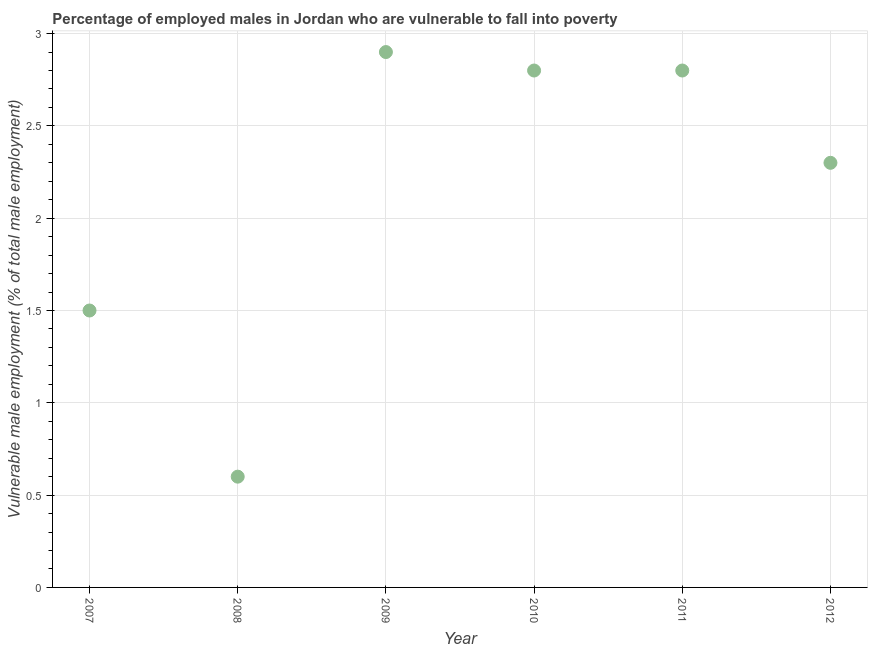What is the percentage of employed males who are vulnerable to fall into poverty in 2007?
Give a very brief answer. 1.5. Across all years, what is the maximum percentage of employed males who are vulnerable to fall into poverty?
Provide a succinct answer. 2.9. Across all years, what is the minimum percentage of employed males who are vulnerable to fall into poverty?
Your answer should be very brief. 0.6. In which year was the percentage of employed males who are vulnerable to fall into poverty maximum?
Provide a succinct answer. 2009. What is the sum of the percentage of employed males who are vulnerable to fall into poverty?
Provide a short and direct response. 12.9. What is the average percentage of employed males who are vulnerable to fall into poverty per year?
Your answer should be compact. 2.15. What is the median percentage of employed males who are vulnerable to fall into poverty?
Your answer should be compact. 2.55. What is the ratio of the percentage of employed males who are vulnerable to fall into poverty in 2010 to that in 2012?
Your answer should be very brief. 1.22. Is the percentage of employed males who are vulnerable to fall into poverty in 2009 less than that in 2010?
Provide a succinct answer. No. What is the difference between the highest and the second highest percentage of employed males who are vulnerable to fall into poverty?
Keep it short and to the point. 0.1. What is the difference between the highest and the lowest percentage of employed males who are vulnerable to fall into poverty?
Your answer should be compact. 2.3. Does the percentage of employed males who are vulnerable to fall into poverty monotonically increase over the years?
Offer a very short reply. No. How many dotlines are there?
Provide a short and direct response. 1. Are the values on the major ticks of Y-axis written in scientific E-notation?
Offer a very short reply. No. Does the graph contain grids?
Give a very brief answer. Yes. What is the title of the graph?
Your answer should be very brief. Percentage of employed males in Jordan who are vulnerable to fall into poverty. What is the label or title of the Y-axis?
Your answer should be very brief. Vulnerable male employment (% of total male employment). What is the Vulnerable male employment (% of total male employment) in 2008?
Ensure brevity in your answer.  0.6. What is the Vulnerable male employment (% of total male employment) in 2009?
Offer a very short reply. 2.9. What is the Vulnerable male employment (% of total male employment) in 2010?
Make the answer very short. 2.8. What is the Vulnerable male employment (% of total male employment) in 2011?
Offer a terse response. 2.8. What is the Vulnerable male employment (% of total male employment) in 2012?
Keep it short and to the point. 2.3. What is the difference between the Vulnerable male employment (% of total male employment) in 2007 and 2008?
Your answer should be very brief. 0.9. What is the difference between the Vulnerable male employment (% of total male employment) in 2007 and 2010?
Provide a short and direct response. -1.3. What is the difference between the Vulnerable male employment (% of total male employment) in 2007 and 2012?
Offer a very short reply. -0.8. What is the difference between the Vulnerable male employment (% of total male employment) in 2008 and 2012?
Ensure brevity in your answer.  -1.7. What is the difference between the Vulnerable male employment (% of total male employment) in 2009 and 2010?
Make the answer very short. 0.1. What is the difference between the Vulnerable male employment (% of total male employment) in 2009 and 2011?
Make the answer very short. 0.1. What is the difference between the Vulnerable male employment (% of total male employment) in 2010 and 2012?
Your answer should be compact. 0.5. What is the ratio of the Vulnerable male employment (% of total male employment) in 2007 to that in 2008?
Provide a short and direct response. 2.5. What is the ratio of the Vulnerable male employment (% of total male employment) in 2007 to that in 2009?
Make the answer very short. 0.52. What is the ratio of the Vulnerable male employment (% of total male employment) in 2007 to that in 2010?
Provide a short and direct response. 0.54. What is the ratio of the Vulnerable male employment (% of total male employment) in 2007 to that in 2011?
Make the answer very short. 0.54. What is the ratio of the Vulnerable male employment (% of total male employment) in 2007 to that in 2012?
Your answer should be compact. 0.65. What is the ratio of the Vulnerable male employment (% of total male employment) in 2008 to that in 2009?
Give a very brief answer. 0.21. What is the ratio of the Vulnerable male employment (% of total male employment) in 2008 to that in 2010?
Give a very brief answer. 0.21. What is the ratio of the Vulnerable male employment (% of total male employment) in 2008 to that in 2011?
Offer a terse response. 0.21. What is the ratio of the Vulnerable male employment (% of total male employment) in 2008 to that in 2012?
Provide a succinct answer. 0.26. What is the ratio of the Vulnerable male employment (% of total male employment) in 2009 to that in 2010?
Offer a very short reply. 1.04. What is the ratio of the Vulnerable male employment (% of total male employment) in 2009 to that in 2011?
Provide a short and direct response. 1.04. What is the ratio of the Vulnerable male employment (% of total male employment) in 2009 to that in 2012?
Offer a very short reply. 1.26. What is the ratio of the Vulnerable male employment (% of total male employment) in 2010 to that in 2012?
Keep it short and to the point. 1.22. What is the ratio of the Vulnerable male employment (% of total male employment) in 2011 to that in 2012?
Provide a succinct answer. 1.22. 